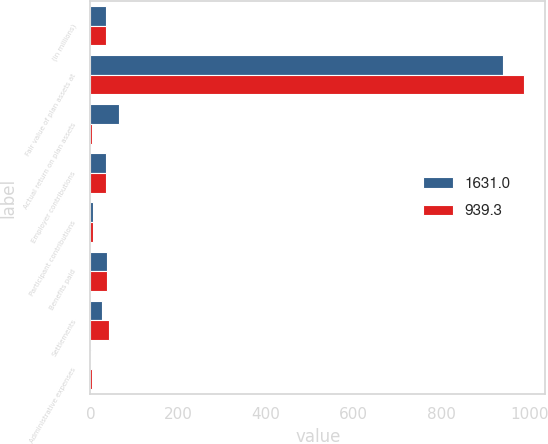Convert chart. <chart><loc_0><loc_0><loc_500><loc_500><stacked_bar_chart><ecel><fcel>(in millions)<fcel>Fair value of plan assets at<fcel>Actual return on plan assets<fcel>Employer contributions<fcel>Participant contributions<fcel>Benefits paid<fcel>Settlements<fcel>Administrative expenses<nl><fcel>1631<fcel>36.05<fcel>939.3<fcel>65.8<fcel>35.7<fcel>6.1<fcel>37.6<fcel>27.1<fcel>1.8<nl><fcel>939.3<fcel>36.05<fcel>987.2<fcel>2.6<fcel>36.4<fcel>6.4<fcel>37.6<fcel>42.7<fcel>3<nl></chart> 